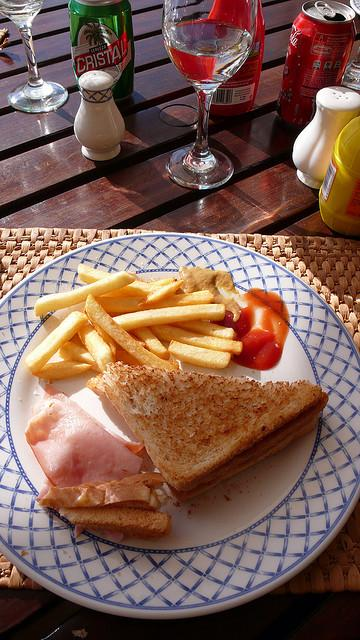Where was this sandwich likely cooked? Please explain your reasoning. grill. This sandwich was most likely grilled, like a grilled cheese. 